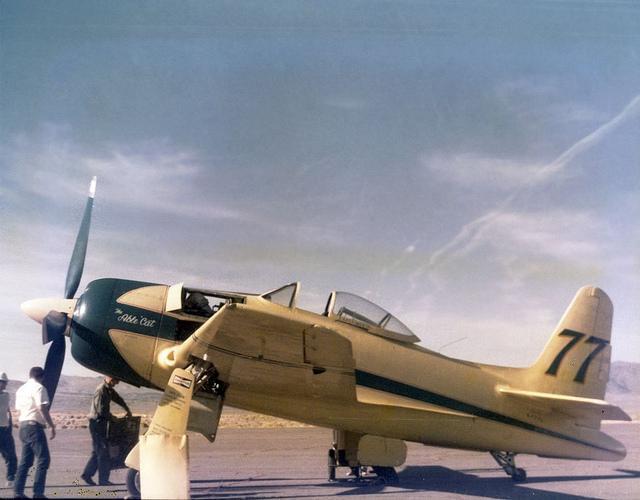How many propellers does the airplane have?
Give a very brief answer. 1. How many people are there?
Give a very brief answer. 2. 